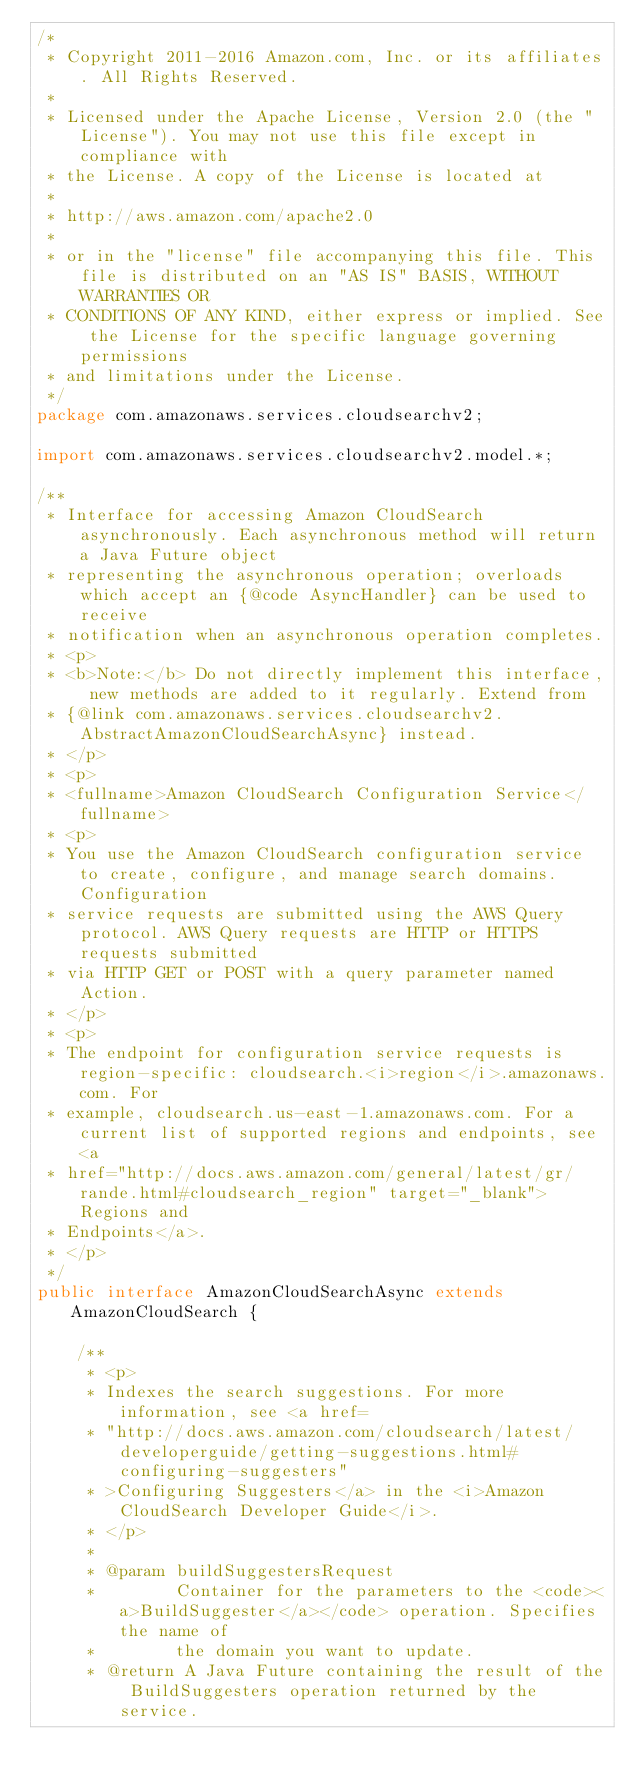Convert code to text. <code><loc_0><loc_0><loc_500><loc_500><_Java_>/*
 * Copyright 2011-2016 Amazon.com, Inc. or its affiliates. All Rights Reserved.
 * 
 * Licensed under the Apache License, Version 2.0 (the "License"). You may not use this file except in compliance with
 * the License. A copy of the License is located at
 * 
 * http://aws.amazon.com/apache2.0
 * 
 * or in the "license" file accompanying this file. This file is distributed on an "AS IS" BASIS, WITHOUT WARRANTIES OR
 * CONDITIONS OF ANY KIND, either express or implied. See the License for the specific language governing permissions
 * and limitations under the License.
 */
package com.amazonaws.services.cloudsearchv2;

import com.amazonaws.services.cloudsearchv2.model.*;

/**
 * Interface for accessing Amazon CloudSearch asynchronously. Each asynchronous method will return a Java Future object
 * representing the asynchronous operation; overloads which accept an {@code AsyncHandler} can be used to receive
 * notification when an asynchronous operation completes.
 * <p>
 * <b>Note:</b> Do not directly implement this interface, new methods are added to it regularly. Extend from
 * {@link com.amazonaws.services.cloudsearchv2.AbstractAmazonCloudSearchAsync} instead.
 * </p>
 * <p>
 * <fullname>Amazon CloudSearch Configuration Service</fullname>
 * <p>
 * You use the Amazon CloudSearch configuration service to create, configure, and manage search domains. Configuration
 * service requests are submitted using the AWS Query protocol. AWS Query requests are HTTP or HTTPS requests submitted
 * via HTTP GET or POST with a query parameter named Action.
 * </p>
 * <p>
 * The endpoint for configuration service requests is region-specific: cloudsearch.<i>region</i>.amazonaws.com. For
 * example, cloudsearch.us-east-1.amazonaws.com. For a current list of supported regions and endpoints, see <a
 * href="http://docs.aws.amazon.com/general/latest/gr/rande.html#cloudsearch_region" target="_blank">Regions and
 * Endpoints</a>.
 * </p>
 */
public interface AmazonCloudSearchAsync extends AmazonCloudSearch {

    /**
     * <p>
     * Indexes the search suggestions. For more information, see <a href=
     * "http://docs.aws.amazon.com/cloudsearch/latest/developerguide/getting-suggestions.html#configuring-suggesters"
     * >Configuring Suggesters</a> in the <i>Amazon CloudSearch Developer Guide</i>.
     * </p>
     * 
     * @param buildSuggestersRequest
     *        Container for the parameters to the <code><a>BuildSuggester</a></code> operation. Specifies the name of
     *        the domain you want to update.
     * @return A Java Future containing the result of the BuildSuggesters operation returned by the service.</code> 